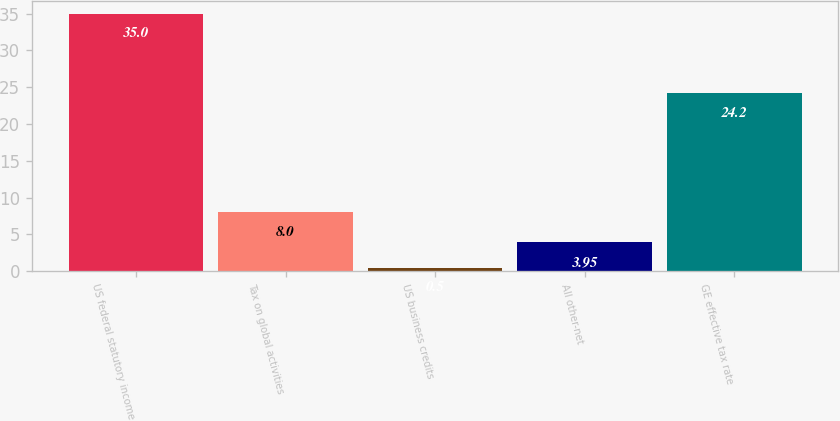Convert chart. <chart><loc_0><loc_0><loc_500><loc_500><bar_chart><fcel>US federal statutory income<fcel>Tax on global activities<fcel>US business credits<fcel>All other-net<fcel>GE effective tax rate<nl><fcel>35<fcel>8<fcel>0.5<fcel>3.95<fcel>24.2<nl></chart> 